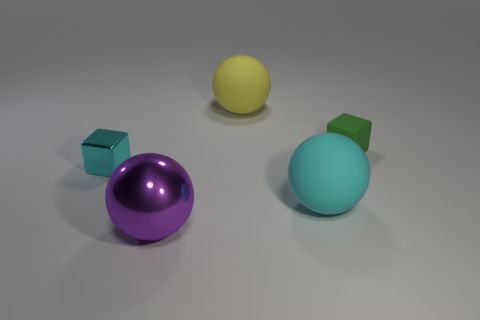How many other things are there of the same shape as the tiny green object? There is only one other object that shares the same cube shape as the tiny green object. It's a larger purple cube situated to the left in the image. 